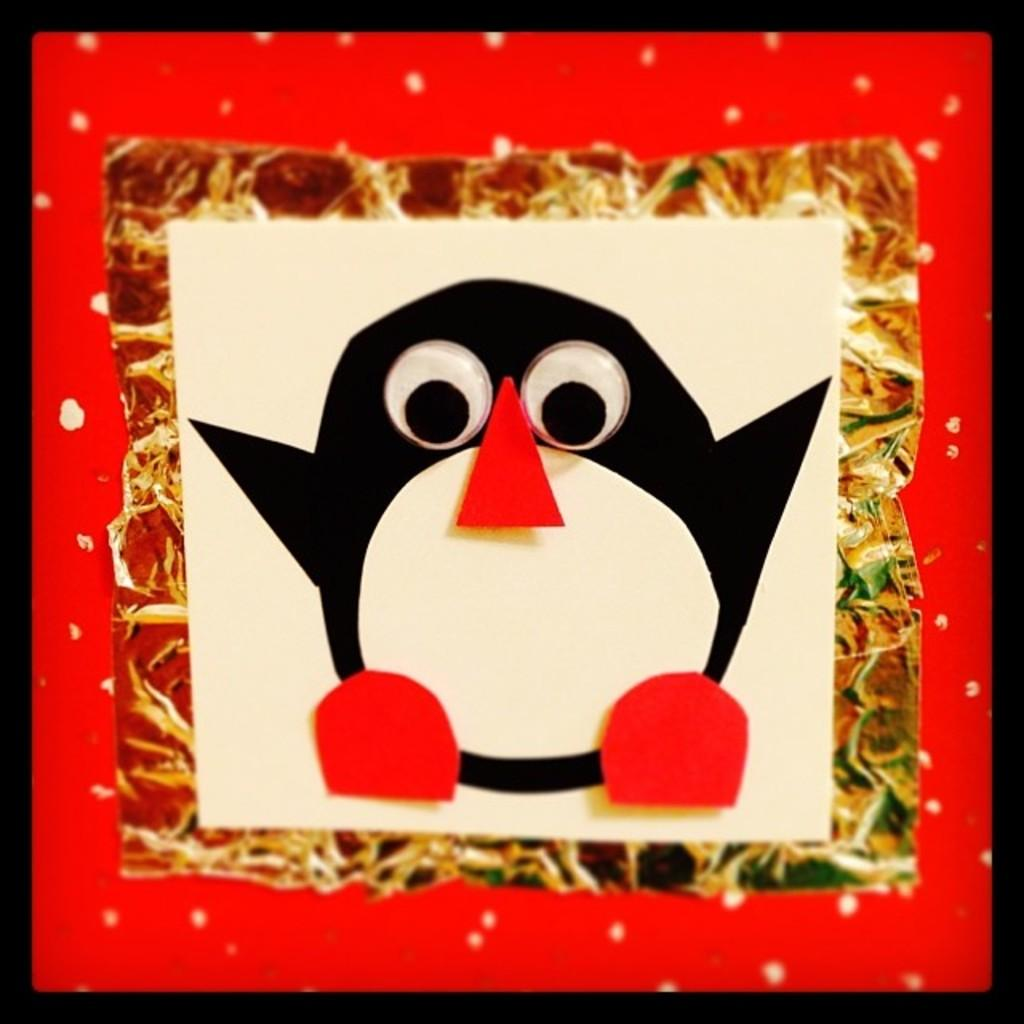What is the main subject of the image? There is a paper craft of a penguin in the image. Can you describe the background of the image? The background of the image is dark. How many veins can be seen in the penguin's paper craft? There are no veins visible in the paper craft of the penguin, as it is made of paper and not a living creature. What type of apples are being used to create the paper craft? There are no apples present in the image, as the main subject is a paper craft of a penguin. 